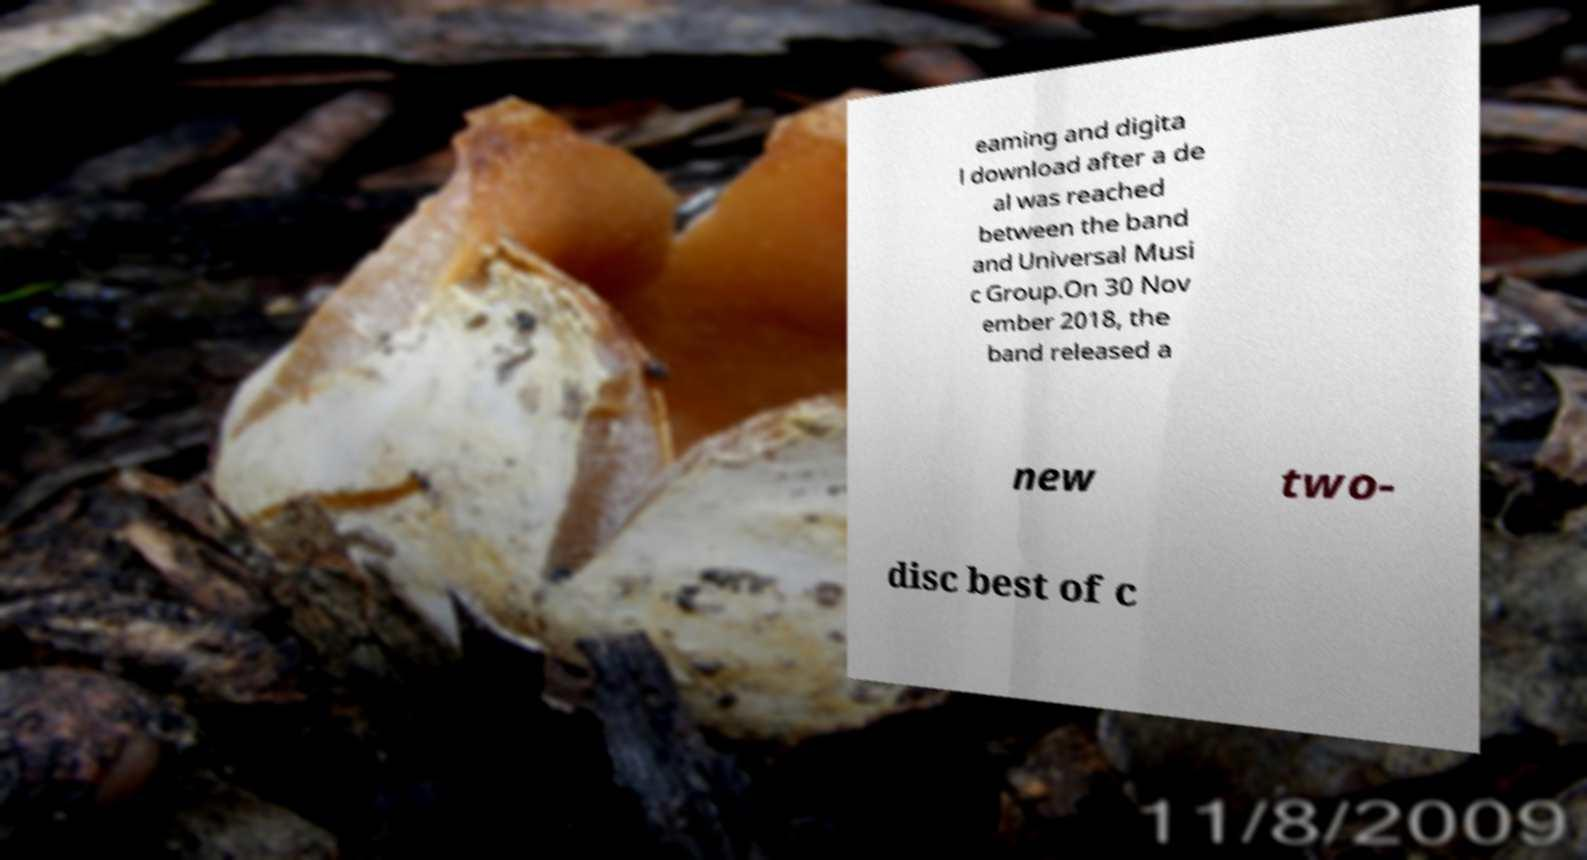Can you accurately transcribe the text from the provided image for me? eaming and digita l download after a de al was reached between the band and Universal Musi c Group.On 30 Nov ember 2018, the band released a new two- disc best of c 